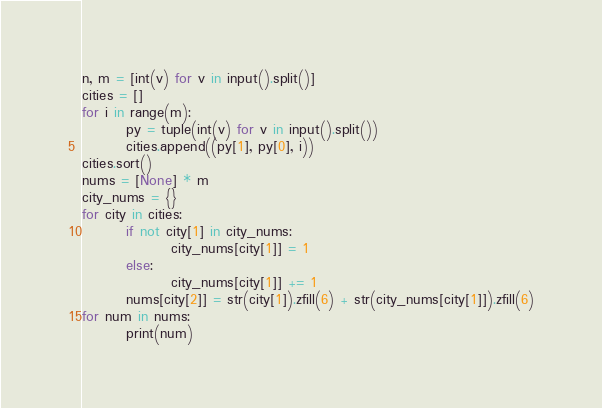Convert code to text. <code><loc_0><loc_0><loc_500><loc_500><_Python_>n, m = [int(v) for v in input().split()]
cities = []
for i in range(m):
        py = tuple(int(v) for v in input().split())
        cities.append((py[1], py[0], i))
cities.sort()
nums = [None] * m
city_nums = {}
for city in cities:
        if not city[1] in city_nums:
                city_nums[city[1]] = 1
        else:
                city_nums[city[1]] += 1
        nums[city[2]] = str(city[1]).zfill(6) + str(city_nums[city[1]]).zfill(6)
for num in nums:
        print(num)</code> 